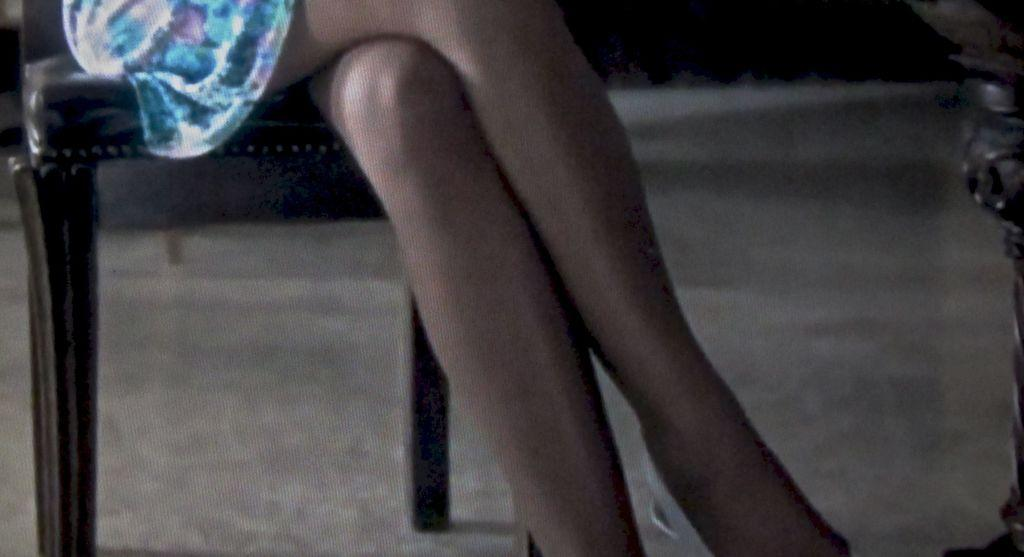What is the main subject of the image? There is a person in the image. What is the person doing in the image? The person is sitting on a chair. What type of hill can be seen in the background of the image? There is no hill visible in the image; it only shows a person sitting on a chair. 